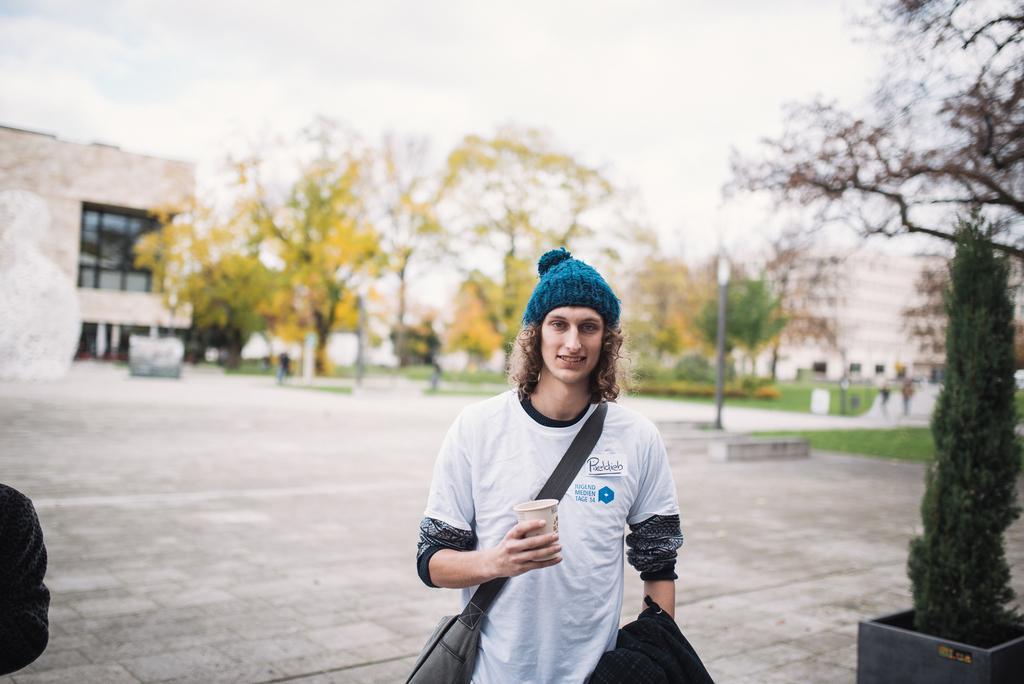Please provide a concise description of this image. In the foreground of this image, there is a man wearing a bag, holding a cup and coat. On the left, there is an object. On the right, there is a tree. In the background, there are buildings, trees, grassland, pavement, a pole and the sky. 